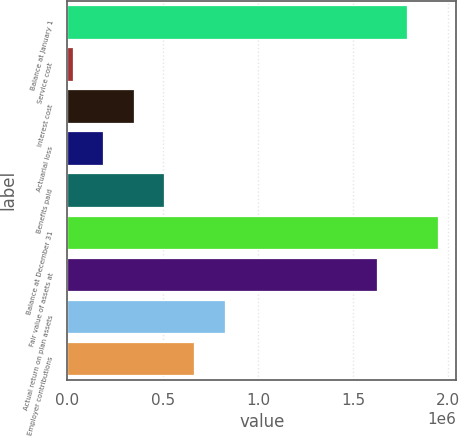Convert chart. <chart><loc_0><loc_0><loc_500><loc_500><bar_chart><fcel>Balance at January 1<fcel>Service cost<fcel>Interest cost<fcel>Actuarial loss<fcel>Benefits paid<fcel>Balance at December 31<fcel>Fair value of assets at<fcel>Actual return on plan assets<fcel>Employer contributions<nl><fcel>1.78384e+06<fcel>28194<fcel>347402<fcel>187798<fcel>507006<fcel>1.94344e+06<fcel>1.62423e+06<fcel>826214<fcel>666610<nl></chart> 